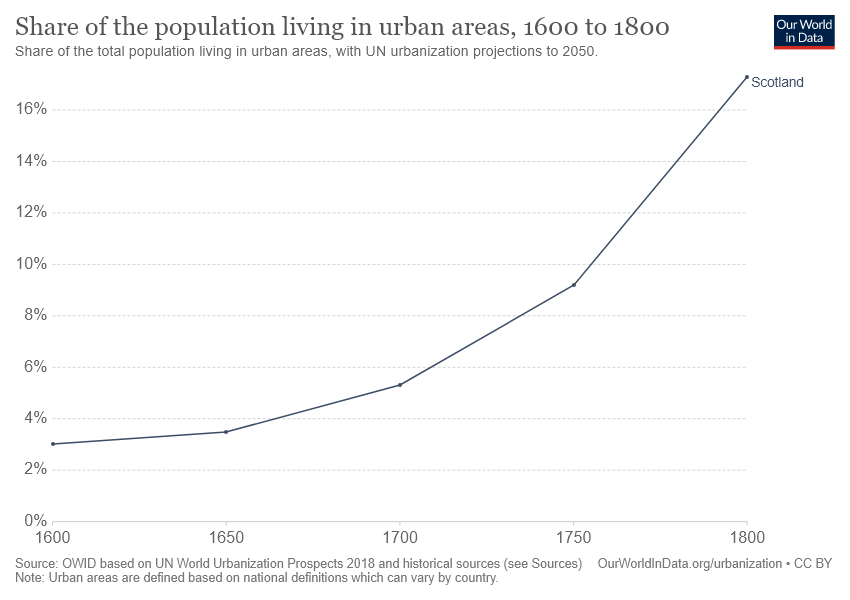Highlight a few significant elements in this photo. The share of the population in Scotland increased. From the year 1800, the share of the population in Scotland has been higher than 16%. 